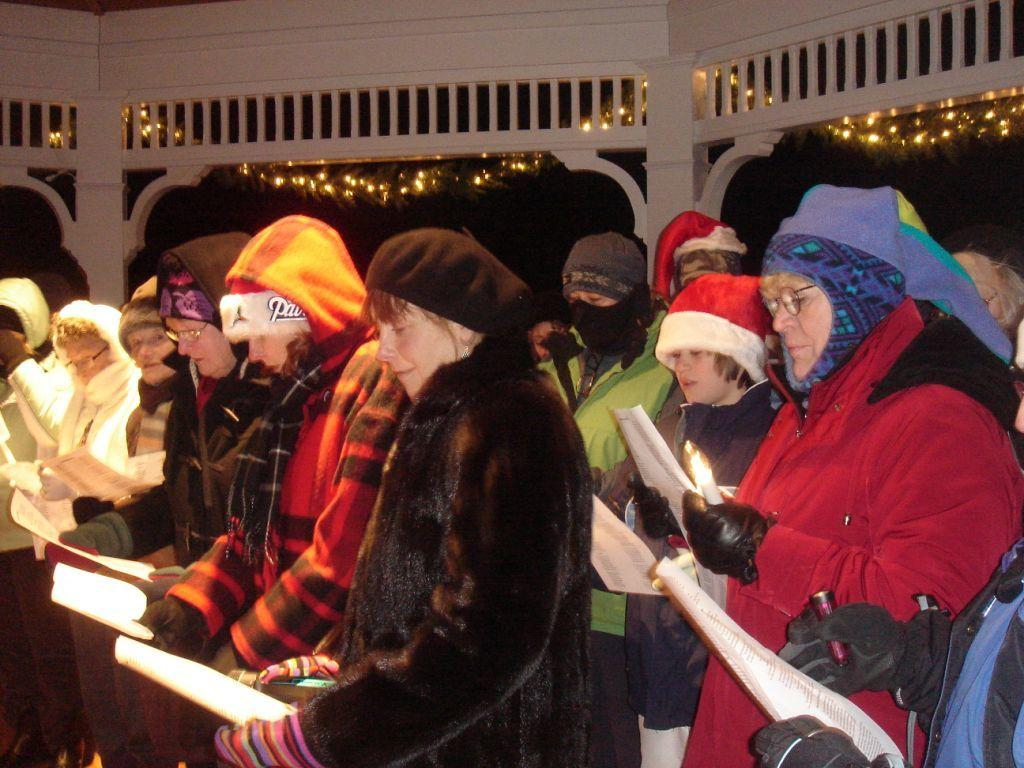Who is present in the image? There are people in the image. What are the people holding in their hands? The people are holding papers in their hands. Can you describe the gender of the people in the image? There are both men and women in the image. What is the color of the background in the image? The background of the image is dark. How many babies are visible in the image? There are no babies present in the image. What type of haircut is the woman in the image getting? There is no haircut being performed in the image. Can you see any badges on the people in the image? There is no mention of badges in the provided facts, so we cannot determine if any are present in the image. 